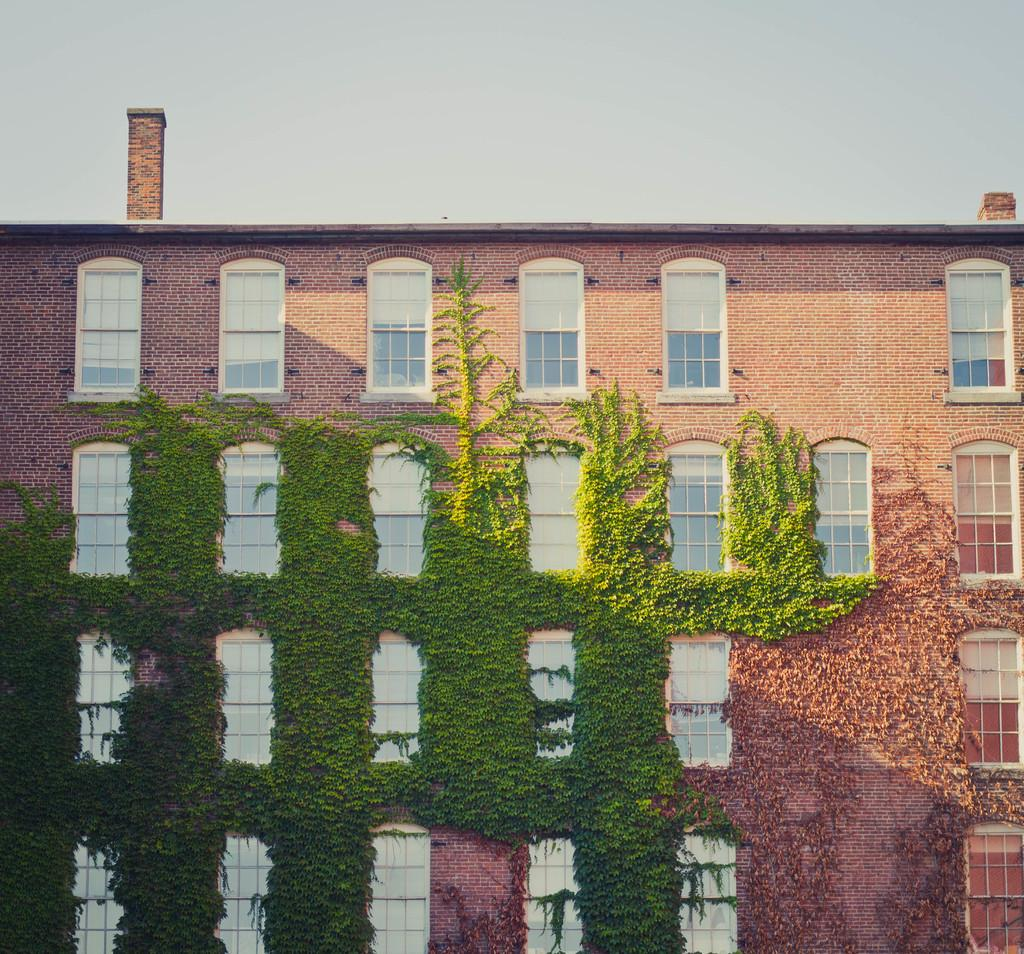What type of structure is present in the image? There is a building in the image. What feature can be seen on the building? The building has windows. What type of vegetation is visible in the image? There is grass visible in the image. What part of the natural environment is visible in the image? The sky is visible in the image. What type of leather is being used to cover the snakes in the image? There are no snakes or leather present in the image; it features a building with windows and a grassy area with the sky visible. 